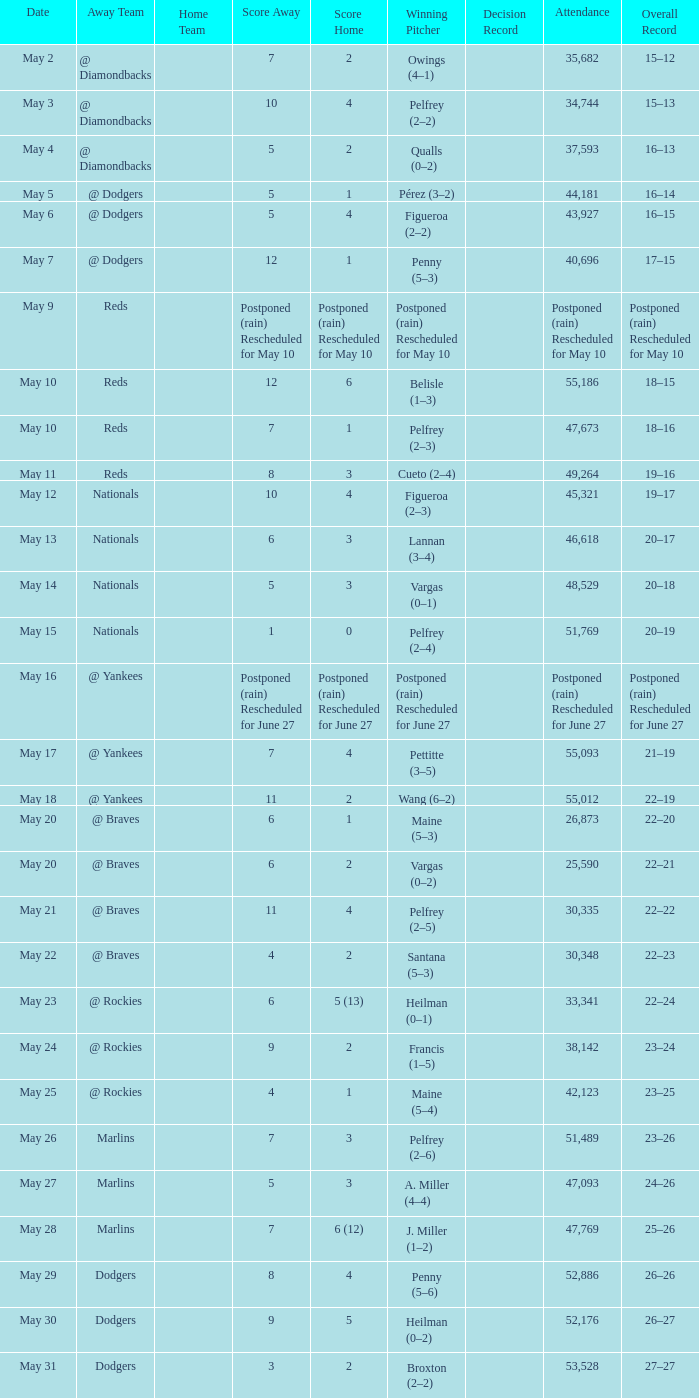Score of postponed (rain) rescheduled for June 27 had what loss? Postponed (rain) Rescheduled for June 27. 